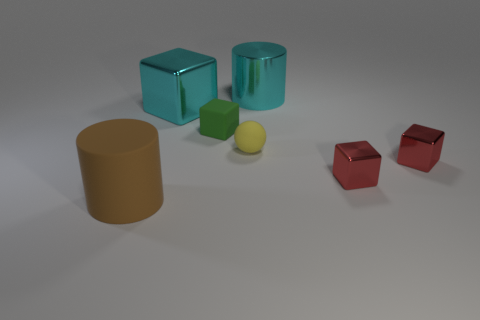Subtract all red spheres. Subtract all purple cylinders. How many spheres are left? 1 Add 1 yellow objects. How many objects exist? 8 Subtract all cylinders. How many objects are left? 5 Subtract 0 brown cubes. How many objects are left? 7 Subtract all tiny yellow rubber balls. Subtract all red metal objects. How many objects are left? 4 Add 7 cyan cubes. How many cyan cubes are left? 8 Add 4 brown cylinders. How many brown cylinders exist? 5 